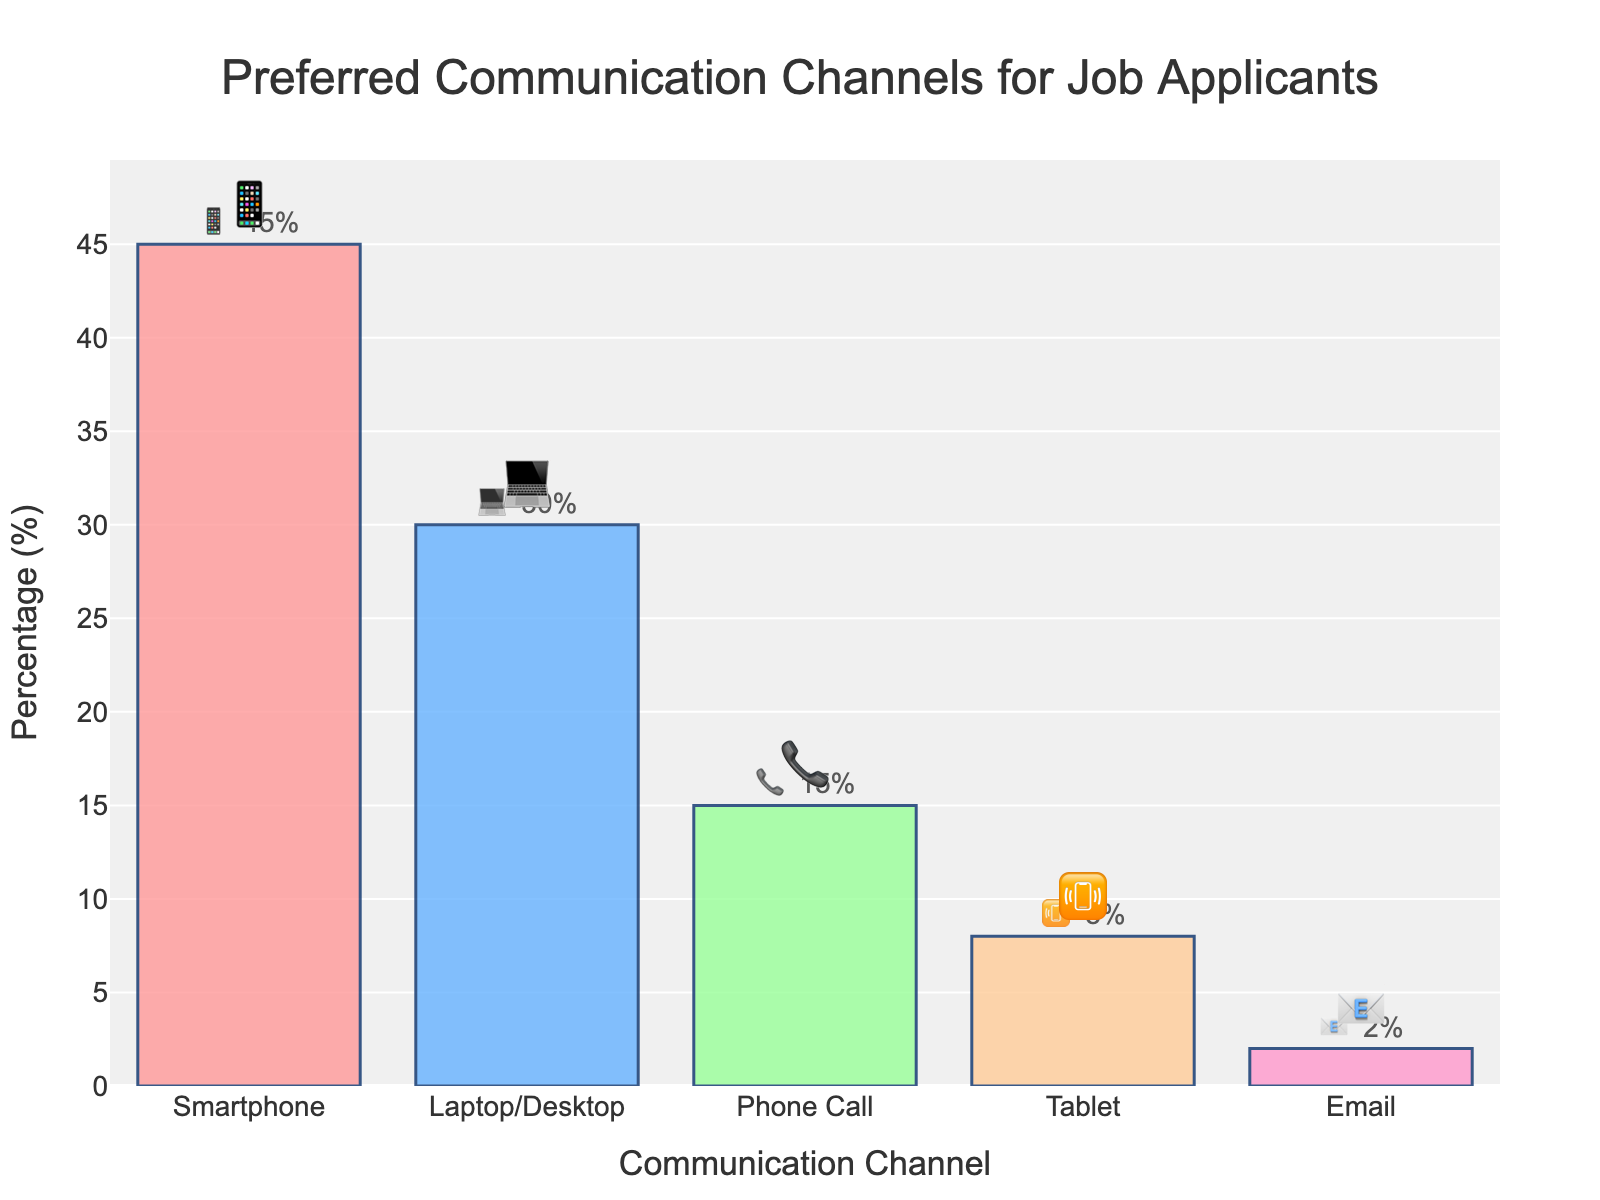What is the title of the chart? The title of the chart is written at the top center of the figure.
Answer: Preferred Communication Channels for Job Applicants Which communication channel is represented by the 📱 emoji? To find out which channel the 📱 emoji represents, you can look at the bar with this emoji in the text.
Answer: Smartphone What percentage of applicants prefer using a laptop or desktop? To find the percentage for laptops/desktops, refer to the bar labeled "Laptop/Desktop."
Answer: 30% What is the least preferred communication channel and its emoji? The least preferred communication channel is indicated by the smallest bar, and the associated emoji is in the text.
Answer: Email 📧 How many communication channels are represented in the figure? Count the number of unique bars or channels listed on the x-axis of the chart.
Answer: 5 What is the combined percentage of applicants preferring phone call and email? Add the percentages for Phone Call and Email, which are 15% and 2% respectively.
Answer: 17% Which communication channel is more preferred: Tablet 📳 or Phone Call 📞? Compare the heights of the bars labeled "Tablet" and "Phone Call" and their percentages.
Answer: Phone Call 📞 By how many percentage points is the Smartphone 📱 channel more preferred than the Laptop/Desktop 💻 channel? Subtract the percentage for Laptop/Desktop from the percentage for Smartphone: 45% - 30%.
Answer: 15% What communication channel has the second highest preference and what percentage does it hold? By observing the heights of the bars, find the second tallest bar and note its percentage.
Answer: Laptop/Desktop, 30% What's the percentage difference between the most and least preferred communication channels? The percentage difference is found by subtracting the smallest percentage (Email) from the highest percentage (Smartphone).
Answer: 43% 